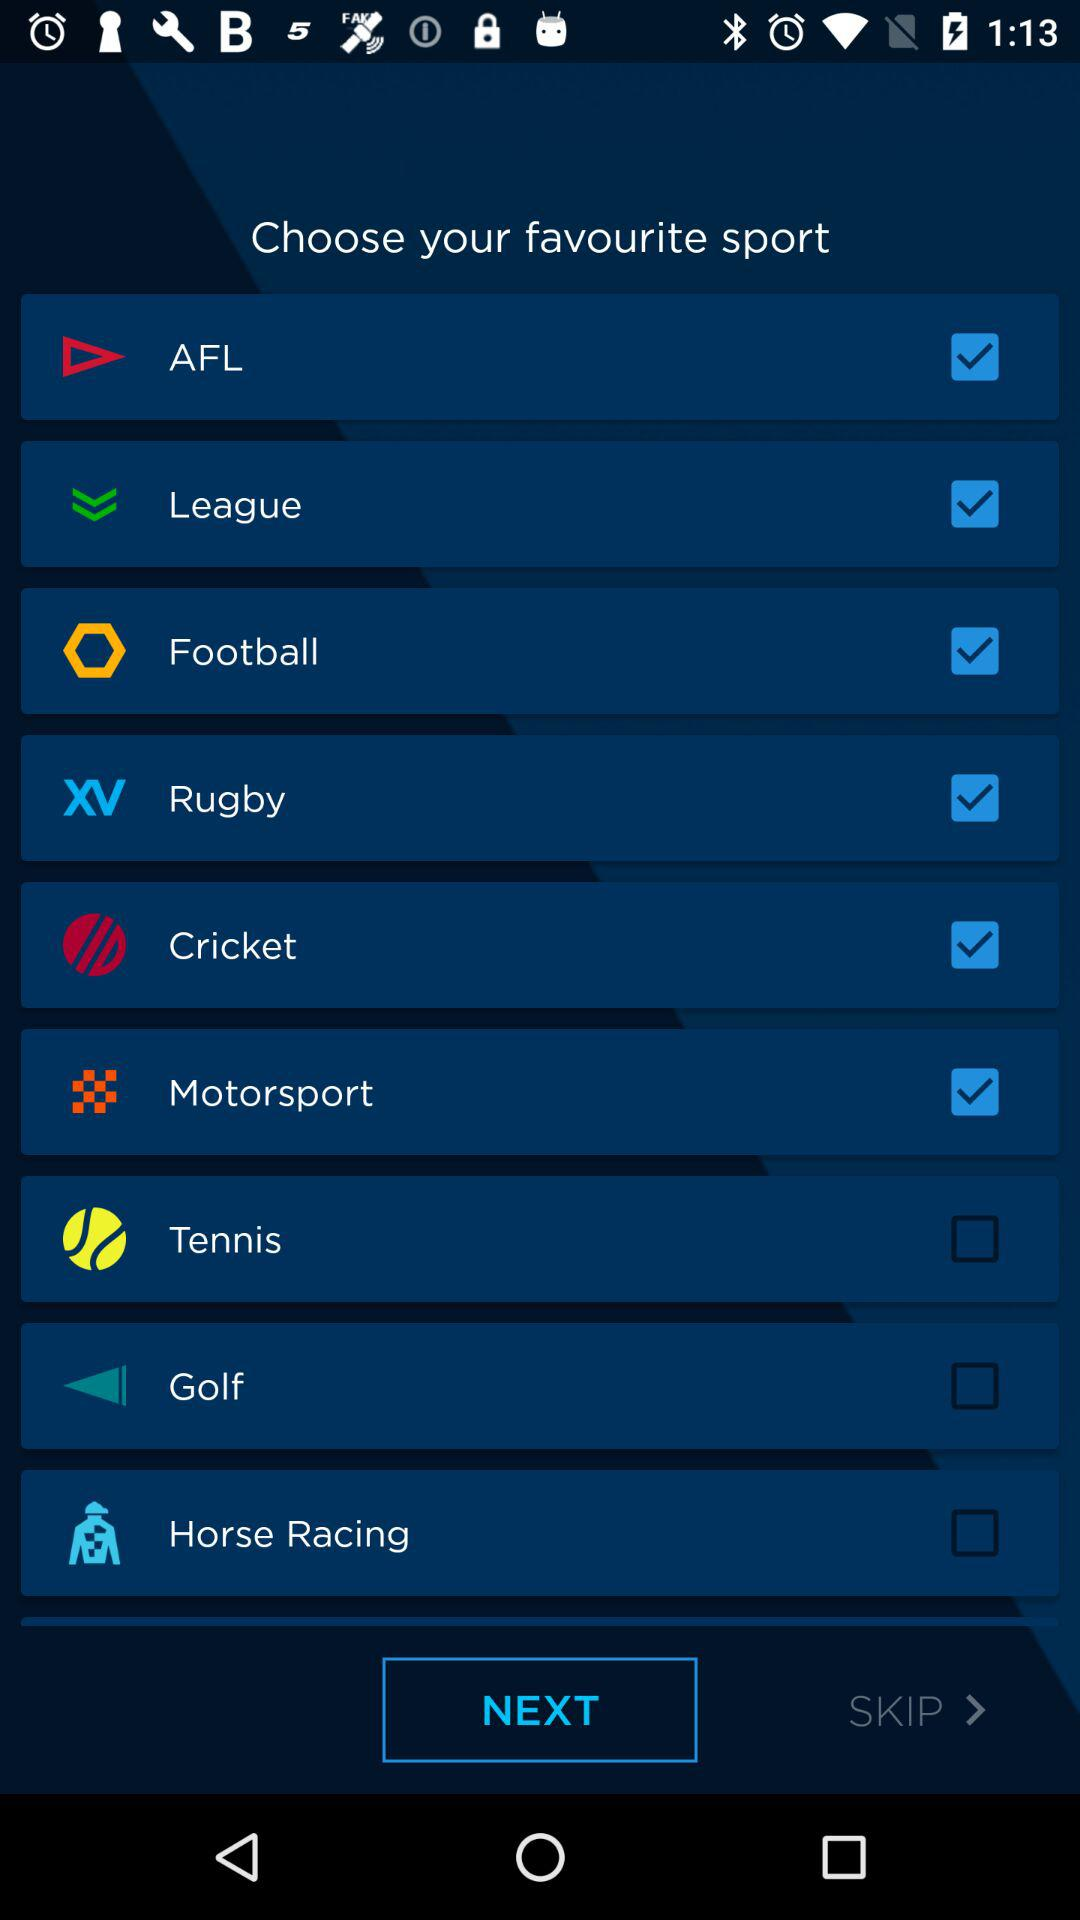What is the status of "Rugby" sport? The status is "on". 